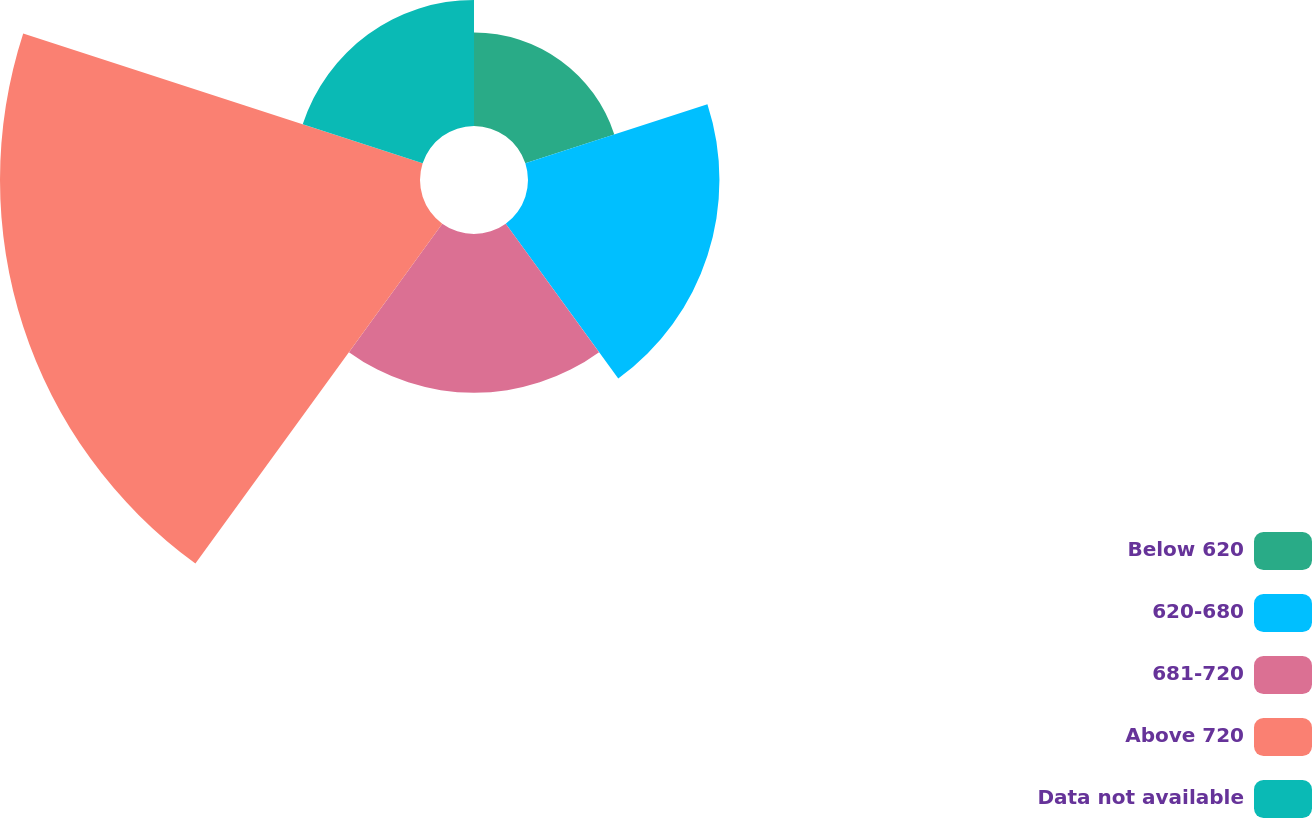Convert chart to OTSL. <chart><loc_0><loc_0><loc_500><loc_500><pie_chart><fcel>Below 620<fcel>620-680<fcel>681-720<fcel>Above 720<fcel>Data not available<nl><fcel>9.45%<fcel>19.34%<fcel>16.04%<fcel>42.43%<fcel>12.74%<nl></chart> 